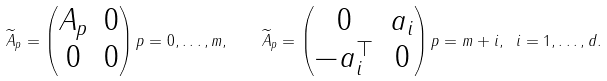<formula> <loc_0><loc_0><loc_500><loc_500>\widetilde { A } _ { p } = \begin{pmatrix} A _ { p } & 0 \\ 0 & 0 \end{pmatrix} p = 0 , \dots , m , \quad \widetilde { A } _ { p } = \begin{pmatrix} 0 & a _ { i } \\ - a _ { i } ^ { \top } & 0 \end{pmatrix} p = m + i , \ i = 1 , \dots , d .</formula> 